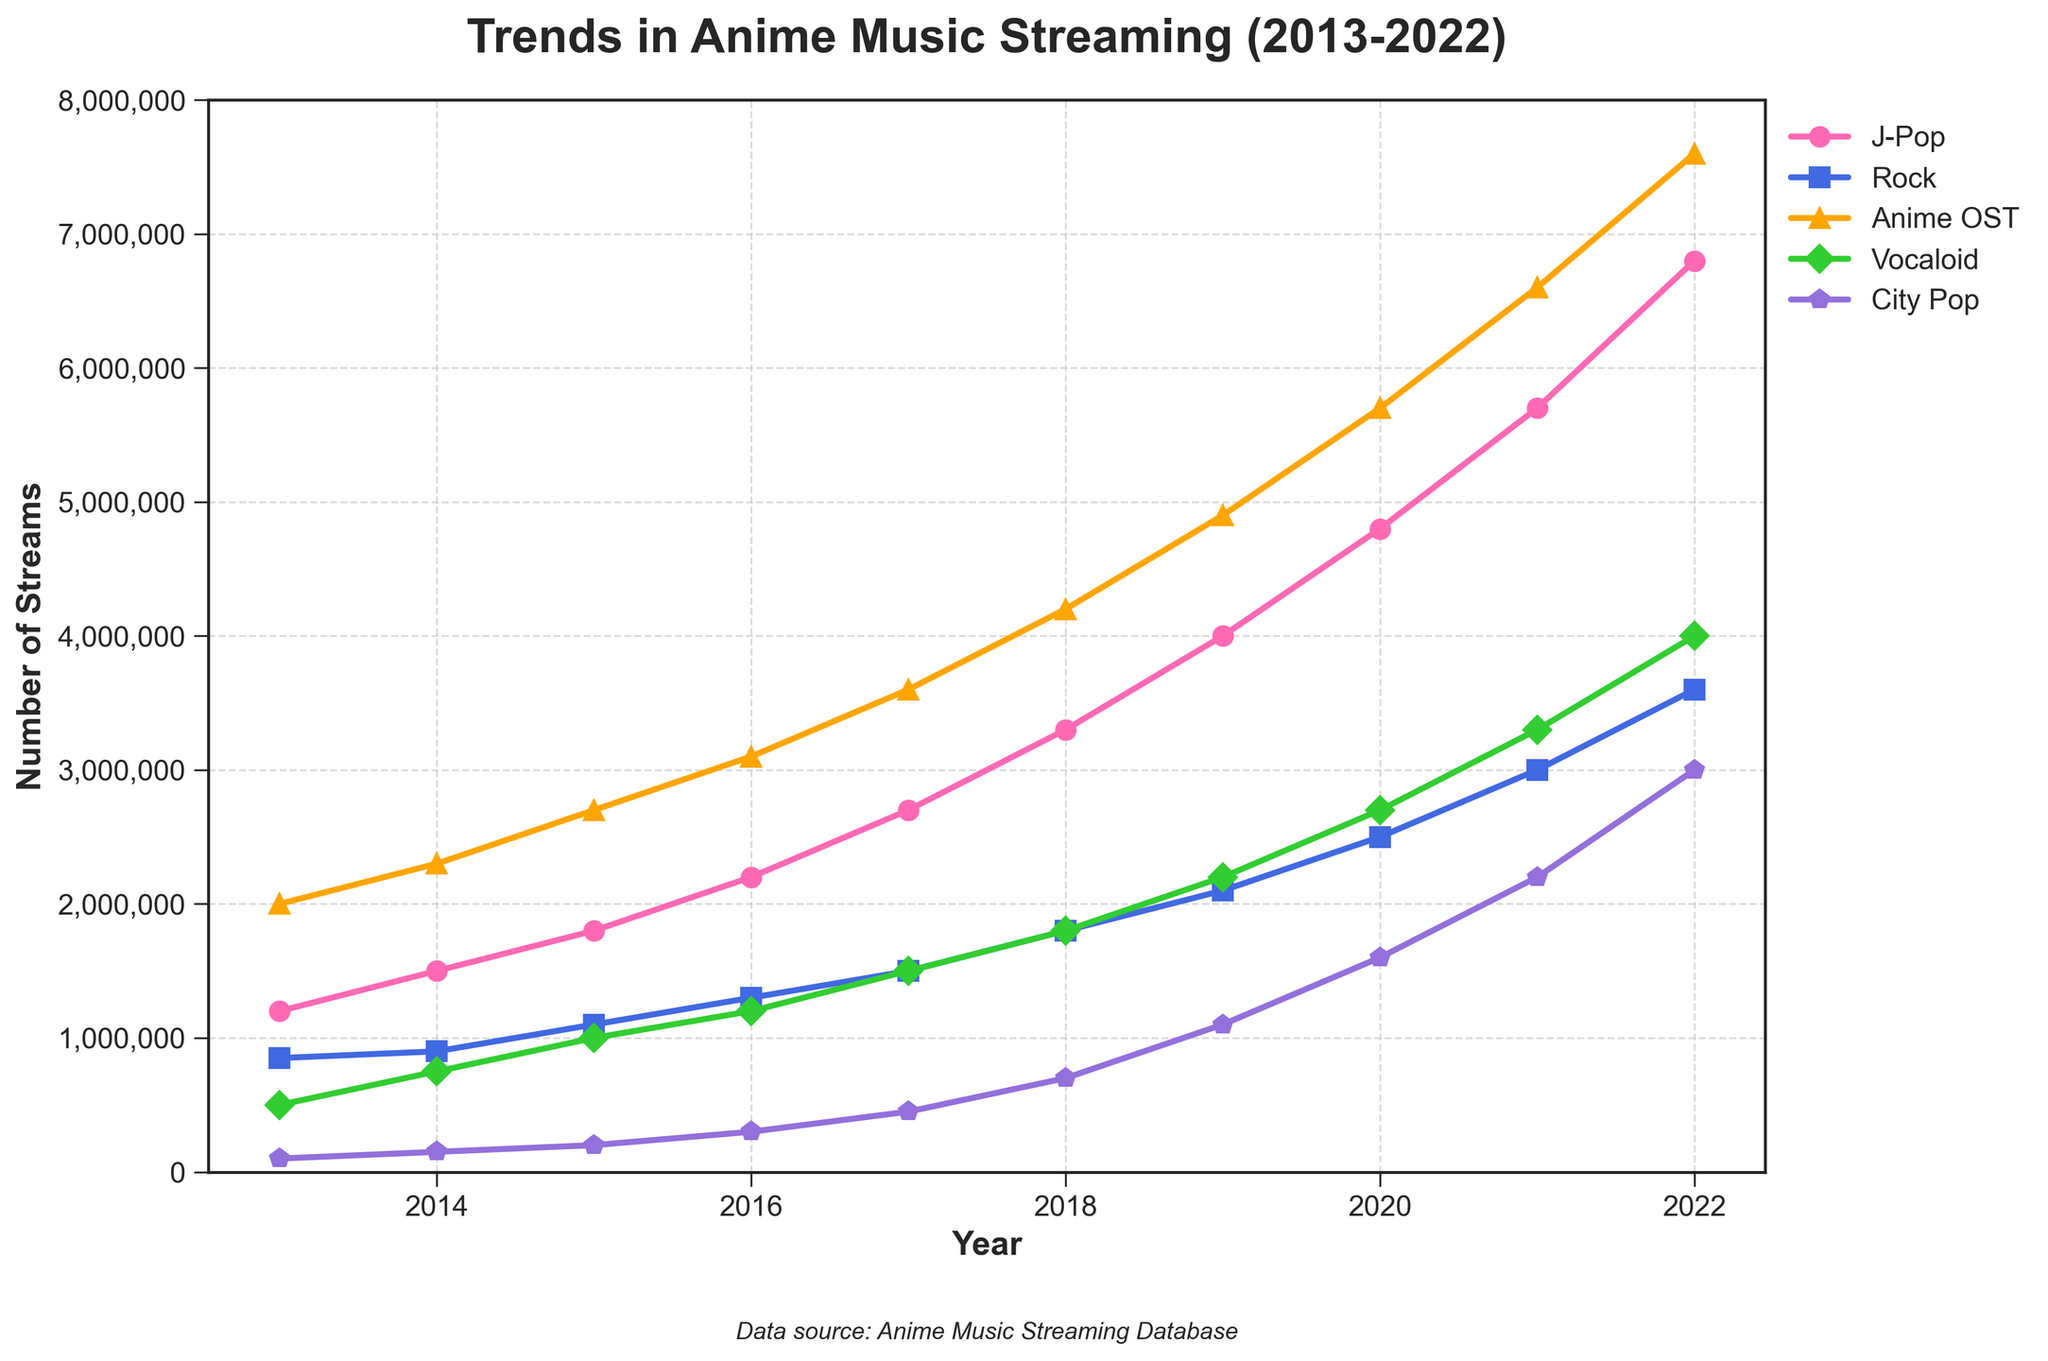Which genre had the highest number of streams in 2022? To determine the genre with the highest number of streams in 2022, look at the endpoint of each line for that year. The 'Anime OST' genre has the highest endpoint.
Answer: Anime OST How did the streaming numbers for J-Pop and Rock compare in 2016? Check the values for J-Pop and Rock in 2016 on the y-axis. J-Pop had 2,200,000 streams and Rock had 1,300,000 streams. Subtract Rock's value from J-Pop's.
Answer: J-Pop had 900,000 more streams What is the overall trend in streaming numbers for the Vocaloid genre from 2013 to 2022? Examine the line for the Vocaloid genre. The line consistently rises from 500,000 in 2013 to 4,000,000 in 2022, indicating a steady increase.
Answer: Steady increase Which genre saw the least growth in streaming numbers over the decade? Calculate the difference in streams between 2013 and 2022 for each genre. City Pop grew from 100,000 to 3,000,000. Though a significant increase, its overall gain is smaller compared to other genres like Anime OST and J-Pop.
Answer: City Pop By how much did the streams for Anime OST increase from 2013 to 2022? Look at the values for Anime OST in 2013 and 2022, which are 2,000,000 and 7,600,000 respectively. Subtract the initial value from the final value.
Answer: Increased by 5,600,000 What was the difference in streams between J-Pop and City Pop in 2015? Check the 2015 values for J-Pop (1,800,000) and City Pop (200,000). Subtract the value of City Pop from J-Pop.
Answer: 1,600,000 Which two genres had the closest number of streams in any year? Analysing the plot, in 2020, Rock had 2,500,000 streams and Vocaloid had 2,700,000 streams. The difference is only 200,000 streams, the least among other years and genres.
Answer: Rock and Vocaloid in 2020 What is the average number of streams for Rock from 2018 to 2022? Sum the values for Rock from 2018 to 2022 (1,800,000 + 2,100,000 + 2,500,000 + 3,000,000 + 3,600,000) and then divide by 5, the number of years.
Answer: 2,600,000 Which genre had more streams in 2015, Vocaloid or J-Pop, and by how much? Check the 2015 values for J-Pop (1,800,000) and Vocaloid (1,000,000). Subtract Vocaloid's value from J-Pop's.
Answer: J-Pop by 800,000 How many genres exceeded 4,000,000 streams in 2021? Look at the values for each genre in 2021. J-Pop (5,700,000), Anime OST (6,600,000), and Vocaloid (3,300,000). Only J-Pop and Anime OST exceed 4,000,000.
Answer: Two genres 